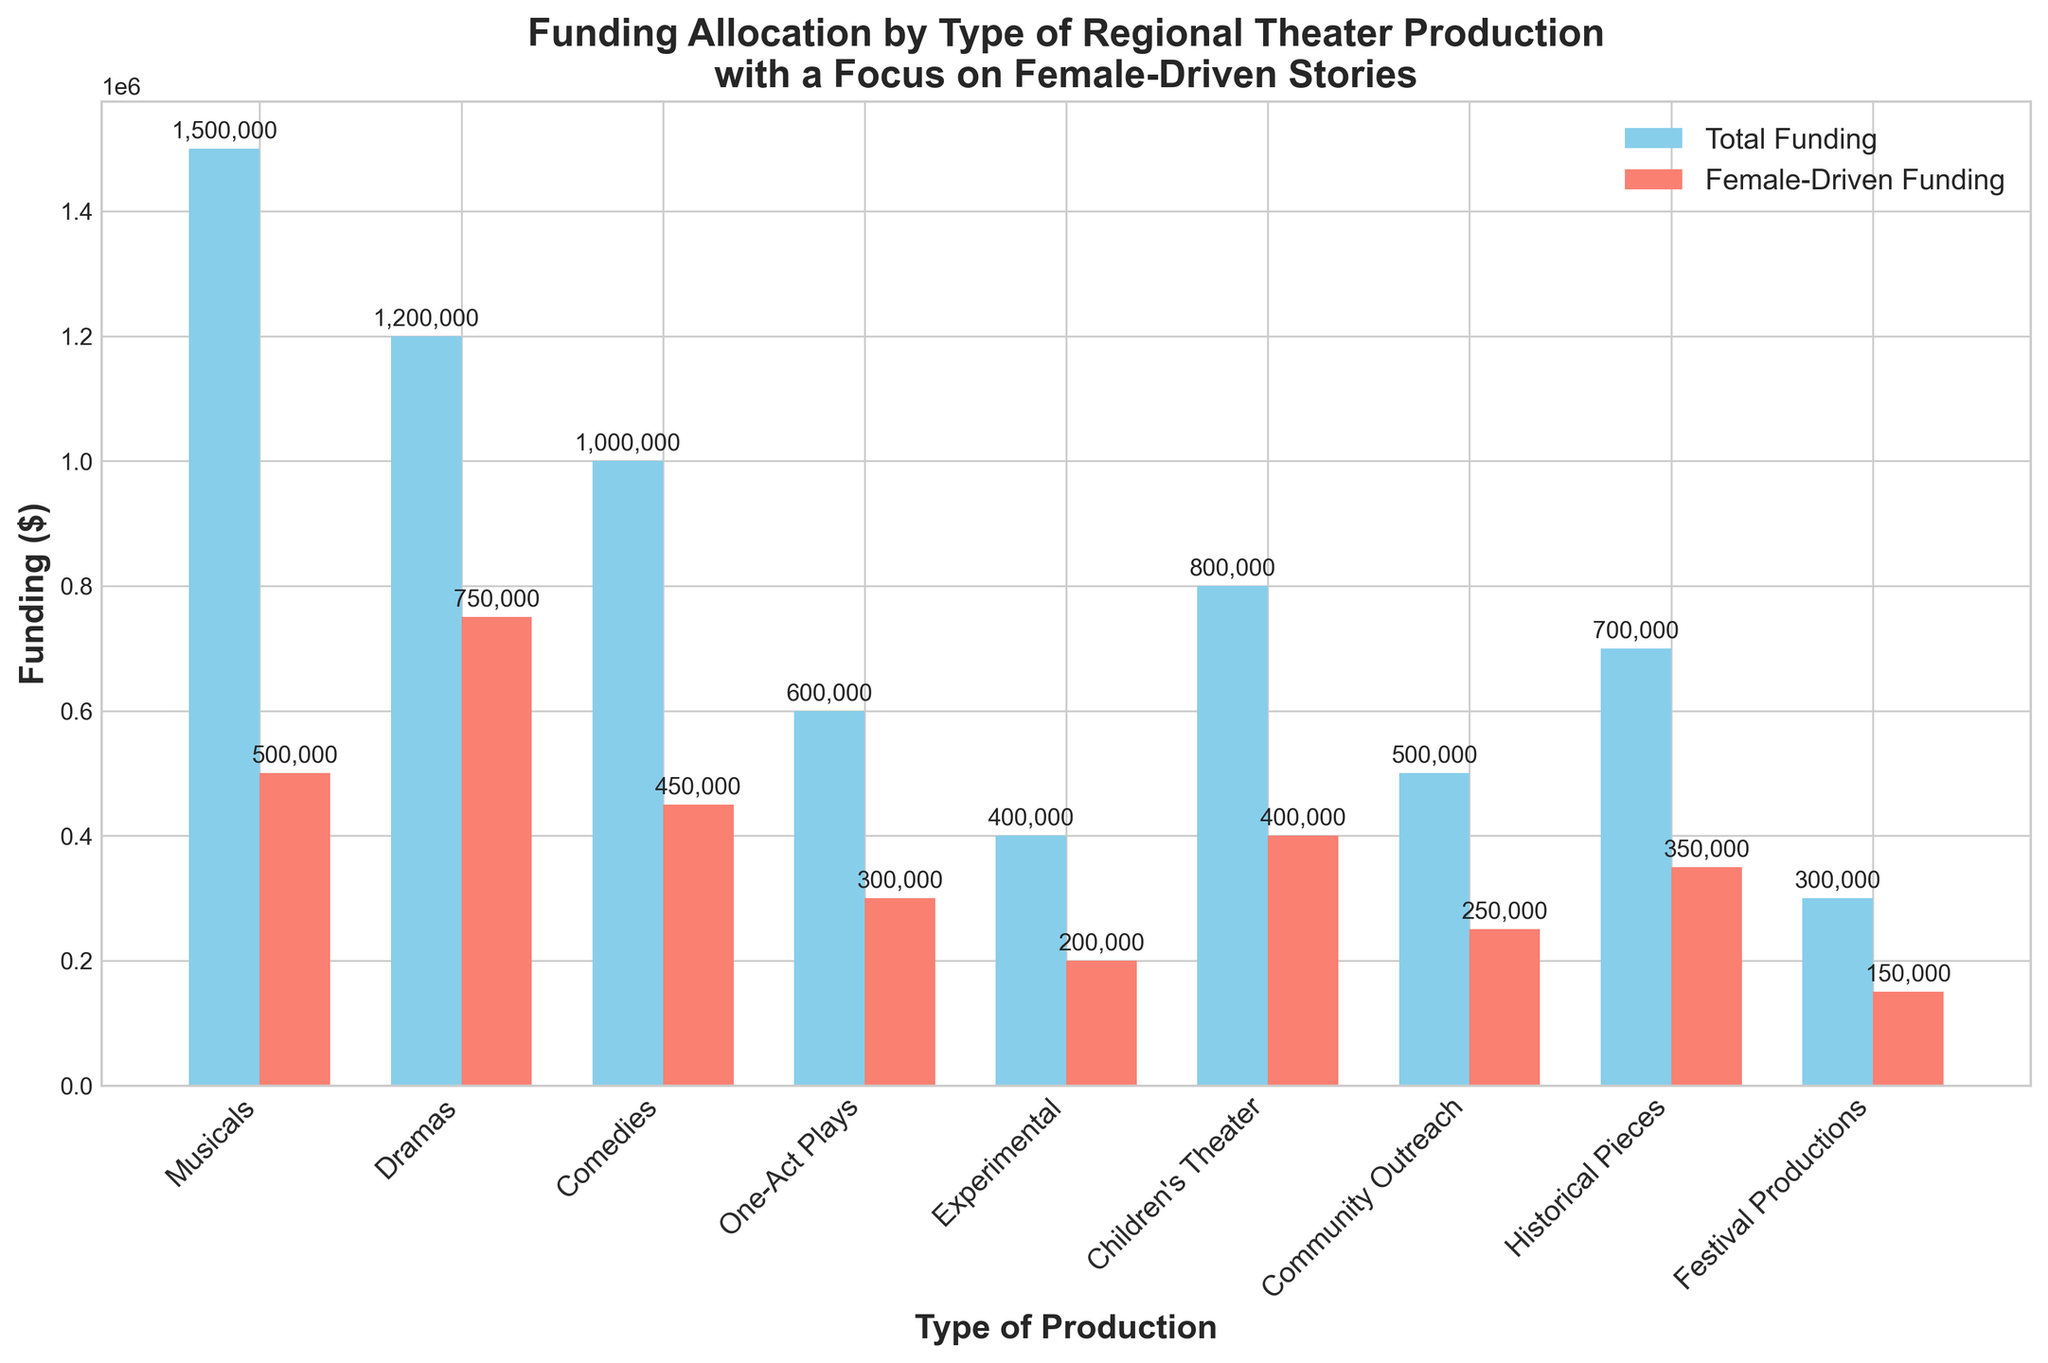Which type of production received the highest total funding? The figure shows bar heights indicating 'Total Funding' for each type of production. The highest bar corresponds to 'Musicals.'
Answer: Musicals Which type of production received the highest female-driven funding? The figure's bars for 'Female-Driven Funding' reveal that 'Dramas' have the highest bar, indicating the most funding.
Answer: Dramas How much more total funding did 'Musicals' receive compared to 'Festival Productions'? The 'Total Funding' bar for 'Musicals' is at $1,500,000, and for 'Festival Productions' it is at $300,000. The difference is $1,500,000 - $300,000 = $1,200,000.
Answer: $1,200,000 What is the average female-driven funding across all types of productions? Sum all 'Female-Driven Funding' values and divide by the number of production types. Adding: $500,000 + $750,000 + $450,000 + $300,000 + $200,000 + $400,000 + $250,000 + $350,000 + $150,000 = $3,350,000. There are 9 production types, so the average is $3,350,000 / 9 = $372,222.22.
Answer: $372,222.22 Compare the total funding for 'Children's Theater' and 'Community Outreach'. Which received more and by how much? The 'Total Funding' for 'Children's Theater' is $800,000, and for 'Community Outreach' it is $500,000. The difference is $800,000 - $500,000 = $300,000.
Answer: Children's Theater by $300,000 Which production type has an equal amount of total and female-driven funding? By examining the bars, each type has a distinct difference between the two funding categories. None of the production types have equal total and female-driven funding.
Answer: None How much total funding did female-driven stories receive for 'Comedies' and 'One-Act Plays' combined? Add the 'Female-Driven Funding' for 'Comedies' ($450,000) and 'One-Act Plays' ($300,000). $450,000 + $300,000 = $750,000.
Answer: $750,000 In 'Dramas', what percentage of the total funding is allocated to female-driven stories? Female-driven funding in 'Dramas' is $750,000, and total funding is $1,200,000. The percentage is ($750,000 / $1,200,000) * 100 = 62.5%.
Answer: 62.5% Is the funding for female-driven plays in 'Children's Theater' greater than half of the total funding for 'Children's Theater'? The 'Female-Driven Funding' for 'Children's Theater' is $400,000, which is exactly half of the total funding ($800,000).
Answer: No Which production type has the smallest gap between total funding and female-driven funding? Calculate the difference for each type by subtracting 'Female-Driven Funding' from 'Total Funding'. The smallest gap is $200,000 for 'Experimental'.
Answer: Experimental 